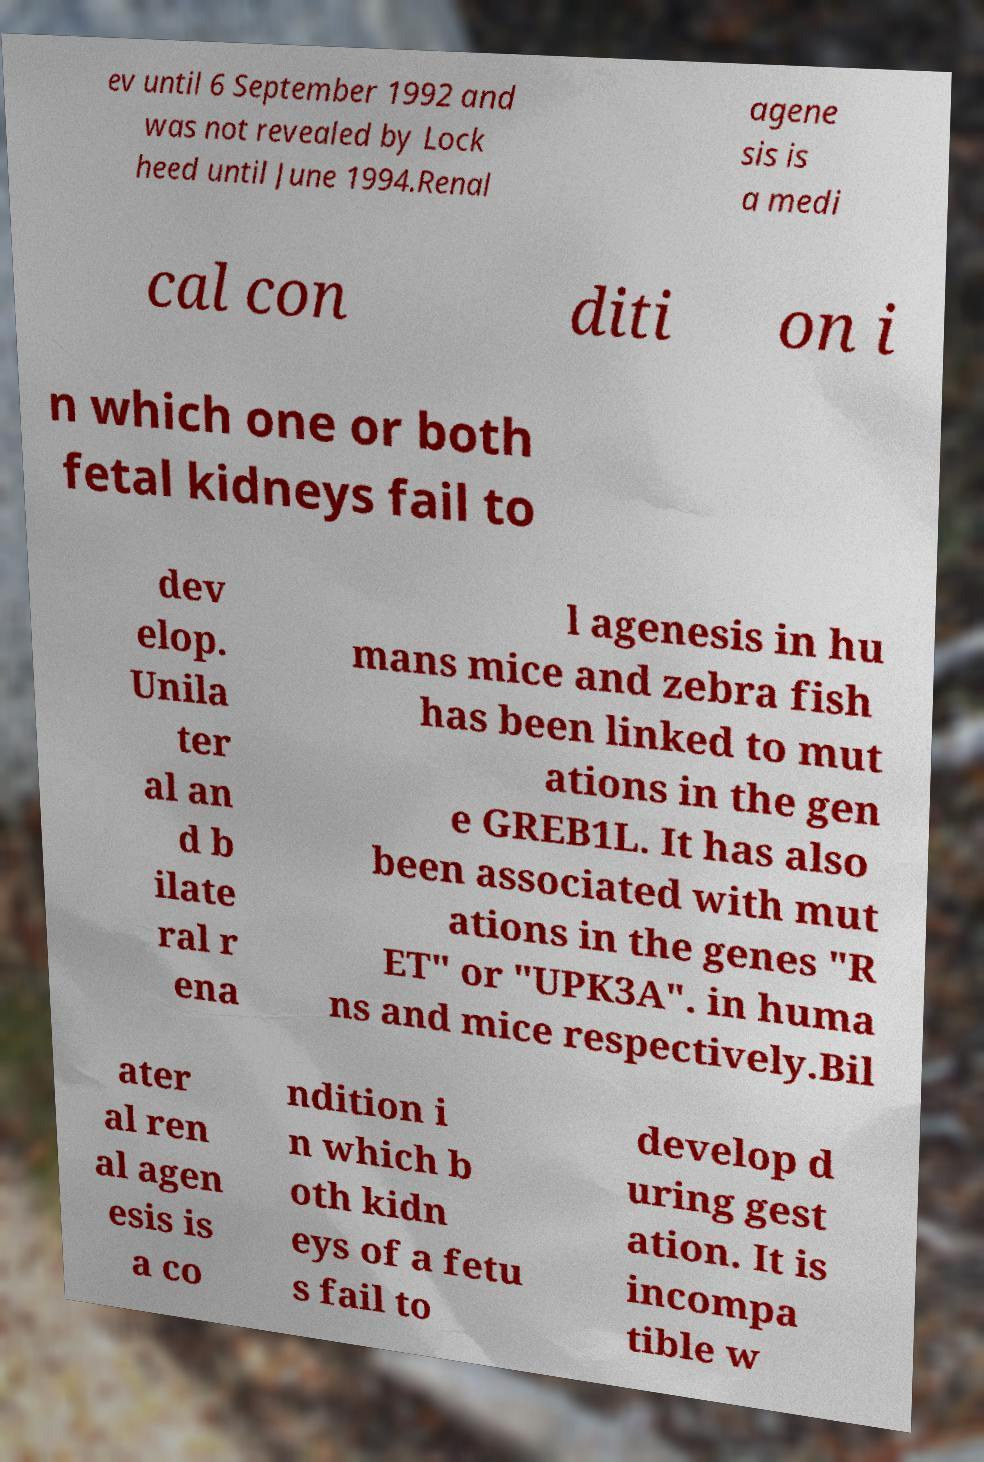Could you assist in decoding the text presented in this image and type it out clearly? ev until 6 September 1992 and was not revealed by Lock heed until June 1994.Renal agene sis is a medi cal con diti on i n which one or both fetal kidneys fail to dev elop. Unila ter al an d b ilate ral r ena l agenesis in hu mans mice and zebra fish has been linked to mut ations in the gen e GREB1L. It has also been associated with mut ations in the genes "R ET" or "UPK3A". in huma ns and mice respectively.Bil ater al ren al agen esis is a co ndition i n which b oth kidn eys of a fetu s fail to develop d uring gest ation. It is incompa tible w 